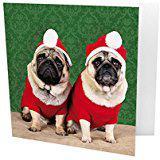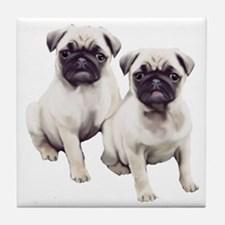The first image is the image on the left, the second image is the image on the right. Evaluate the accuracy of this statement regarding the images: "The combined images include two dogs wearing Santa outfits, including red hats with white pom-poms.". Is it true? Answer yes or no. Yes. The first image is the image on the left, the second image is the image on the right. Assess this claim about the two images: "There are exactly four dogs in total.". Correct or not? Answer yes or no. Yes. 